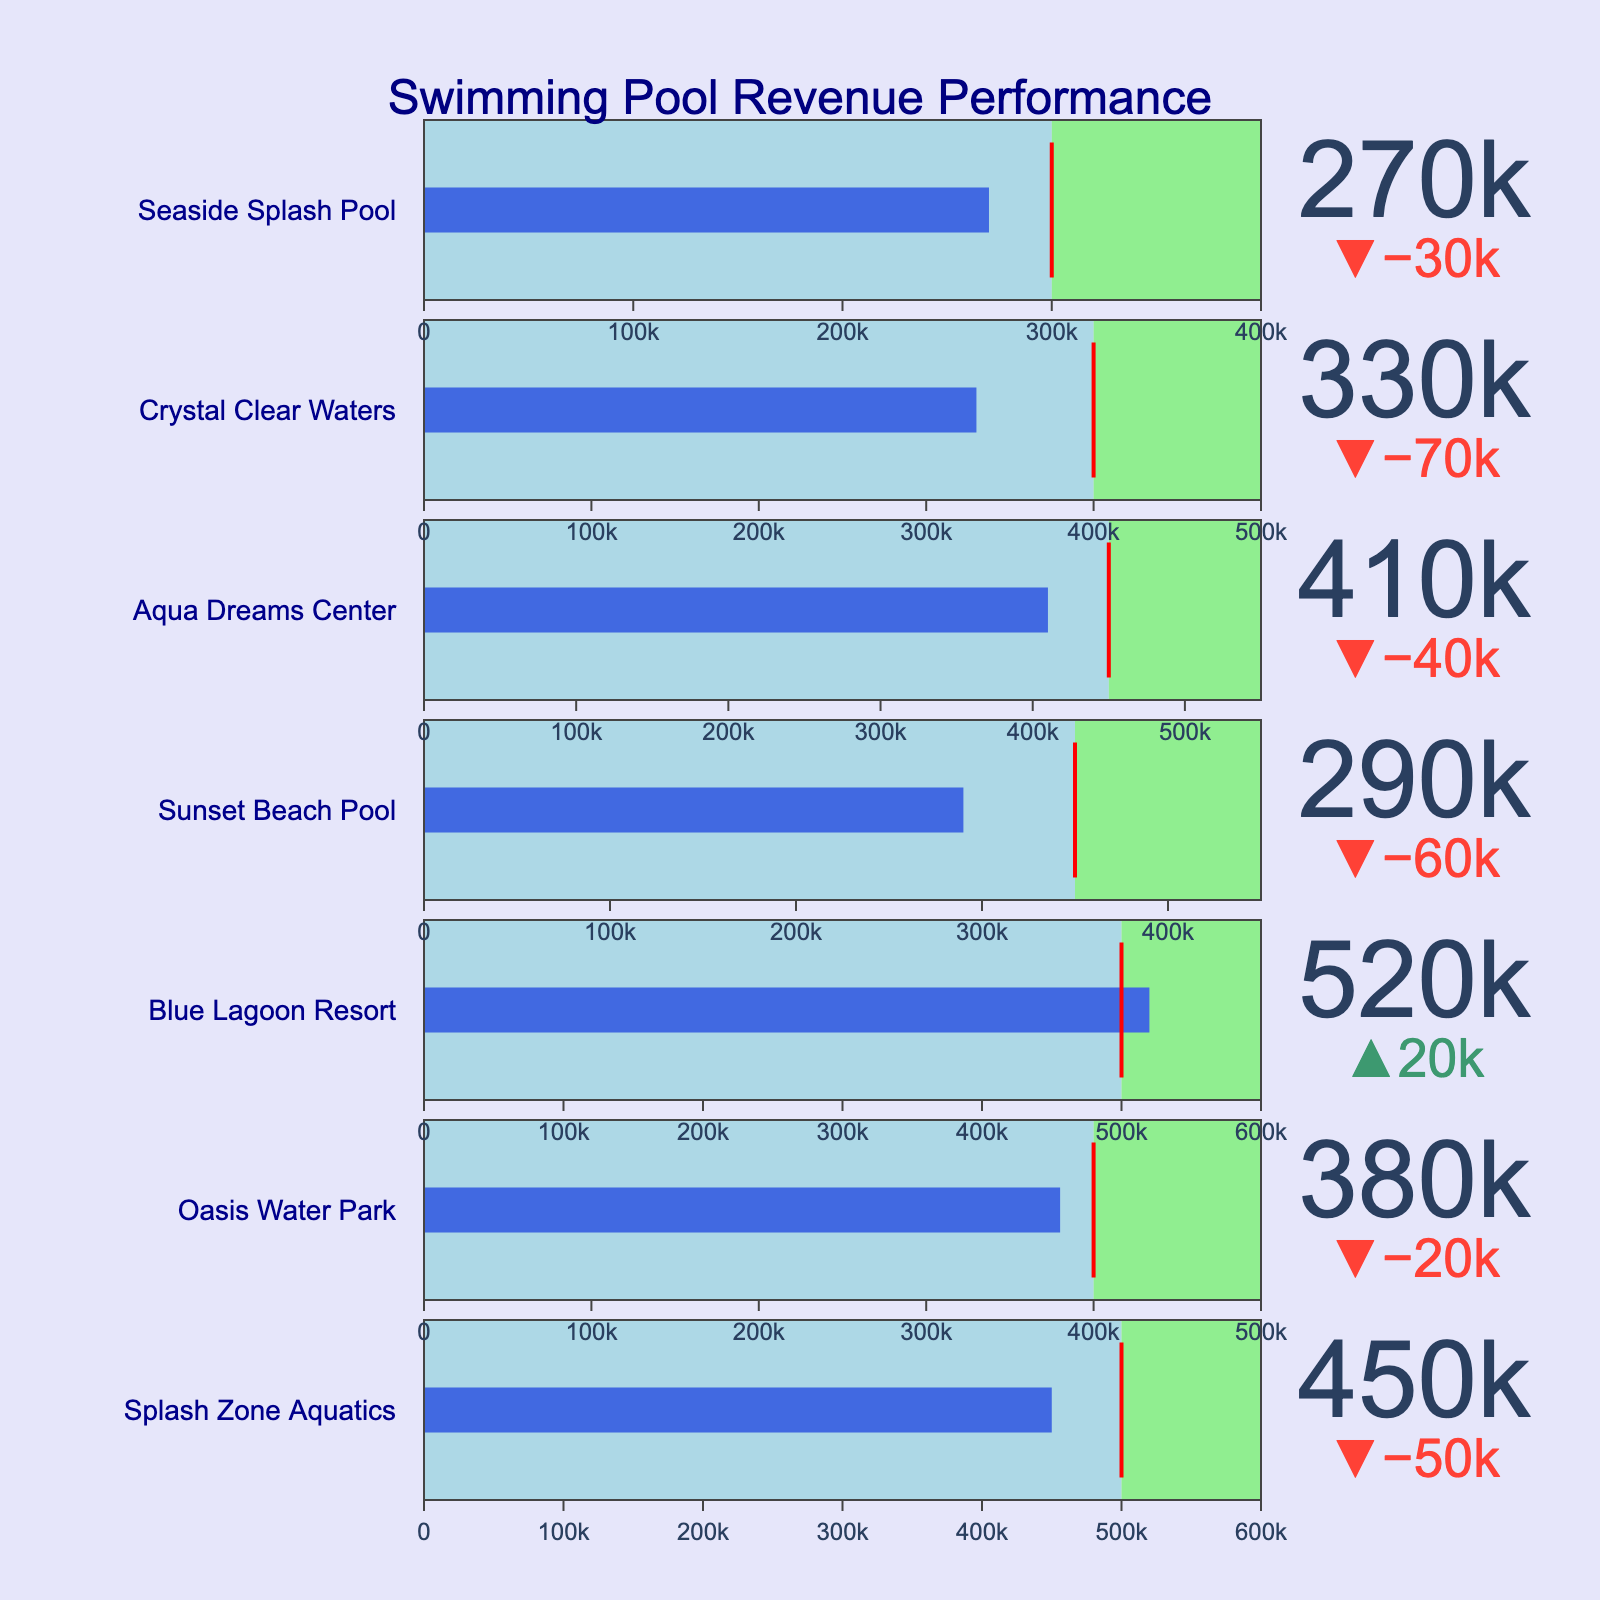What's the title of the figure? The title of the figure is usually placed at the top to provide a summary of what the plot represents.
Answer: Swimming Pool Revenue Performance Which swimming pool has the highest actual revenue? To find this, look at each pool's actual revenue. The bars in the bullet chart represent the actual revenue. The pool with the highest value will have the longest blue bar.
Answer: Blue Lagoon Resort How many pools met or exceeded their target revenue? The actual revenue bar (blue bar) exceeding or reaching the red threshold line indicates the target is met or exceeded. Count the pools where this occurs.
Answer: 2 What is the average target revenue of all the pools? Add the target revenues for all the pools and divide by the number of pools. (500,000 + 400,000 + 500,000 + 350,000 + 450,000 + 400,000 + 300,000) / 7 = 2,900,000 / 7
Answer: 414,286 Which pool has the smallest gap between actual and target revenue? Compare the actual and target revenues for each pool and find the smallest difference.
Answer: Oasis Water Park Which pool is underperforming the most compared to its target revenue? Subtract the target revenue from the actual revenue for each pool. The pool with the most negative difference is underperforming the most.
Answer: Sunset Beach Pool What's the combined maximum revenue of all the pools? Sum the maximum revenue values for all pools. 600,000 + 500,000 + 600,000 + 450,000 + 550,000 + 500,000 + 400,000
Answer: 3,600,000 What color represents the actual revenue in the figure? Observe the color of the bar indicating the actual revenue on the bullet chart.
Answer: royal blue 